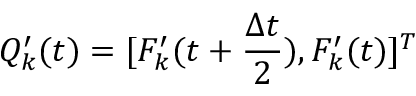Convert formula to latex. <formula><loc_0><loc_0><loc_500><loc_500>Q _ { k } ^ { \prime } ( t ) = [ F _ { k } ^ { \prime } ( t + \frac { \Delta t } { 2 } ) , F _ { k } ^ { \prime } ( t ) ] ^ { T }</formula> 